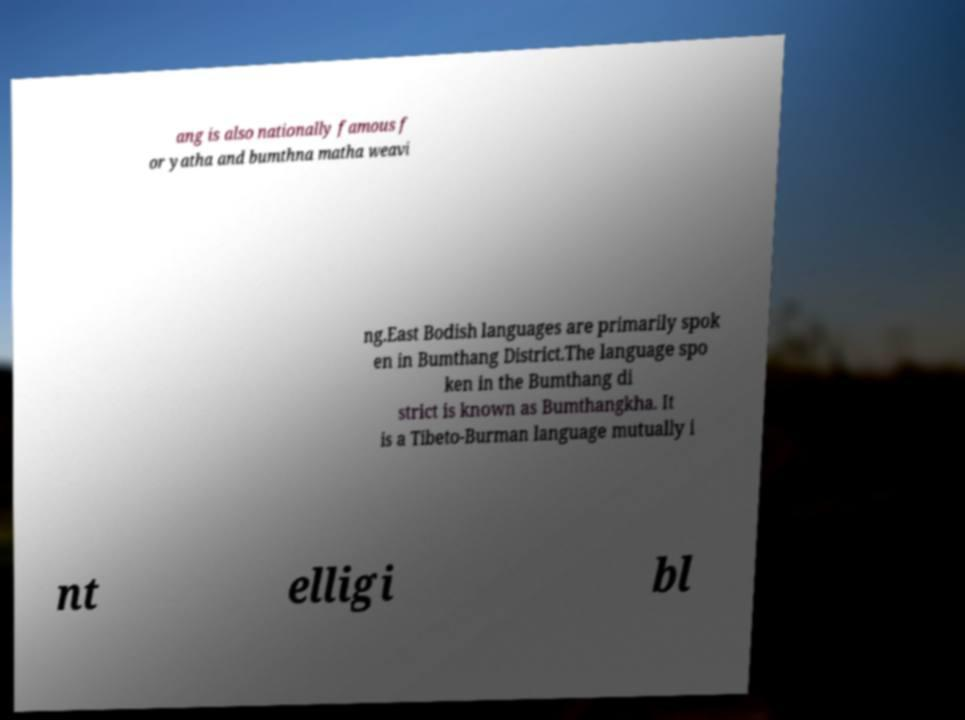Can you accurately transcribe the text from the provided image for me? ang is also nationally famous f or yatha and bumthna matha weavi ng.East Bodish languages are primarily spok en in Bumthang District.The language spo ken in the Bumthang di strict is known as Bumthangkha. It is a Tibeto-Burman language mutually i nt elligi bl 